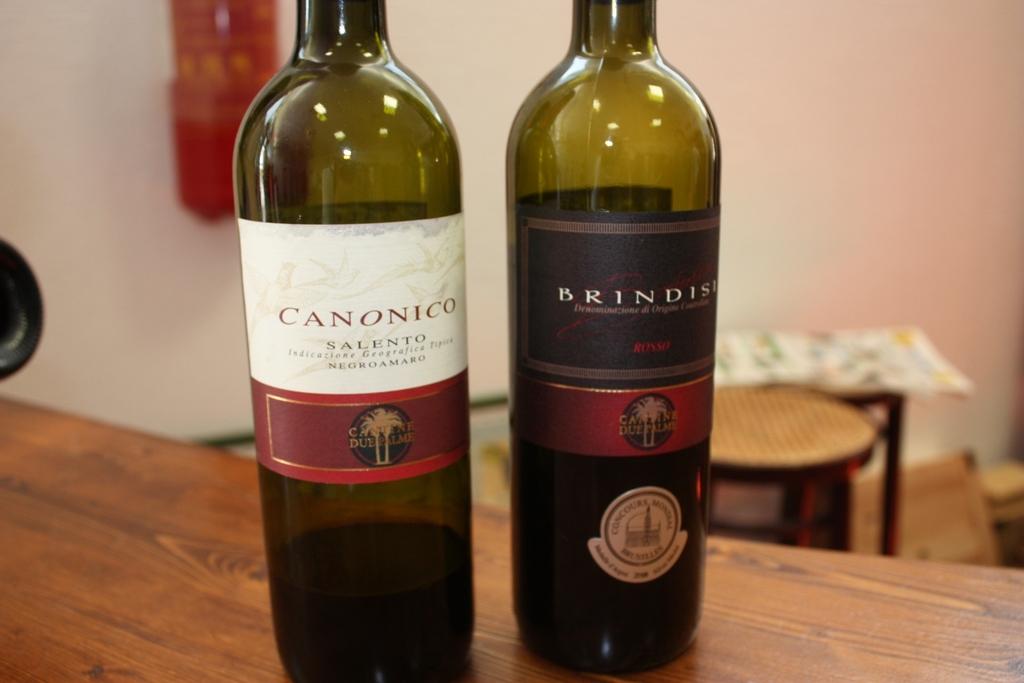What is the name of the wine on the right?
Make the answer very short. Brindisi. What is the name of the wine on the left? it is printed above the word "salento"?
Keep it short and to the point. Canonico. 